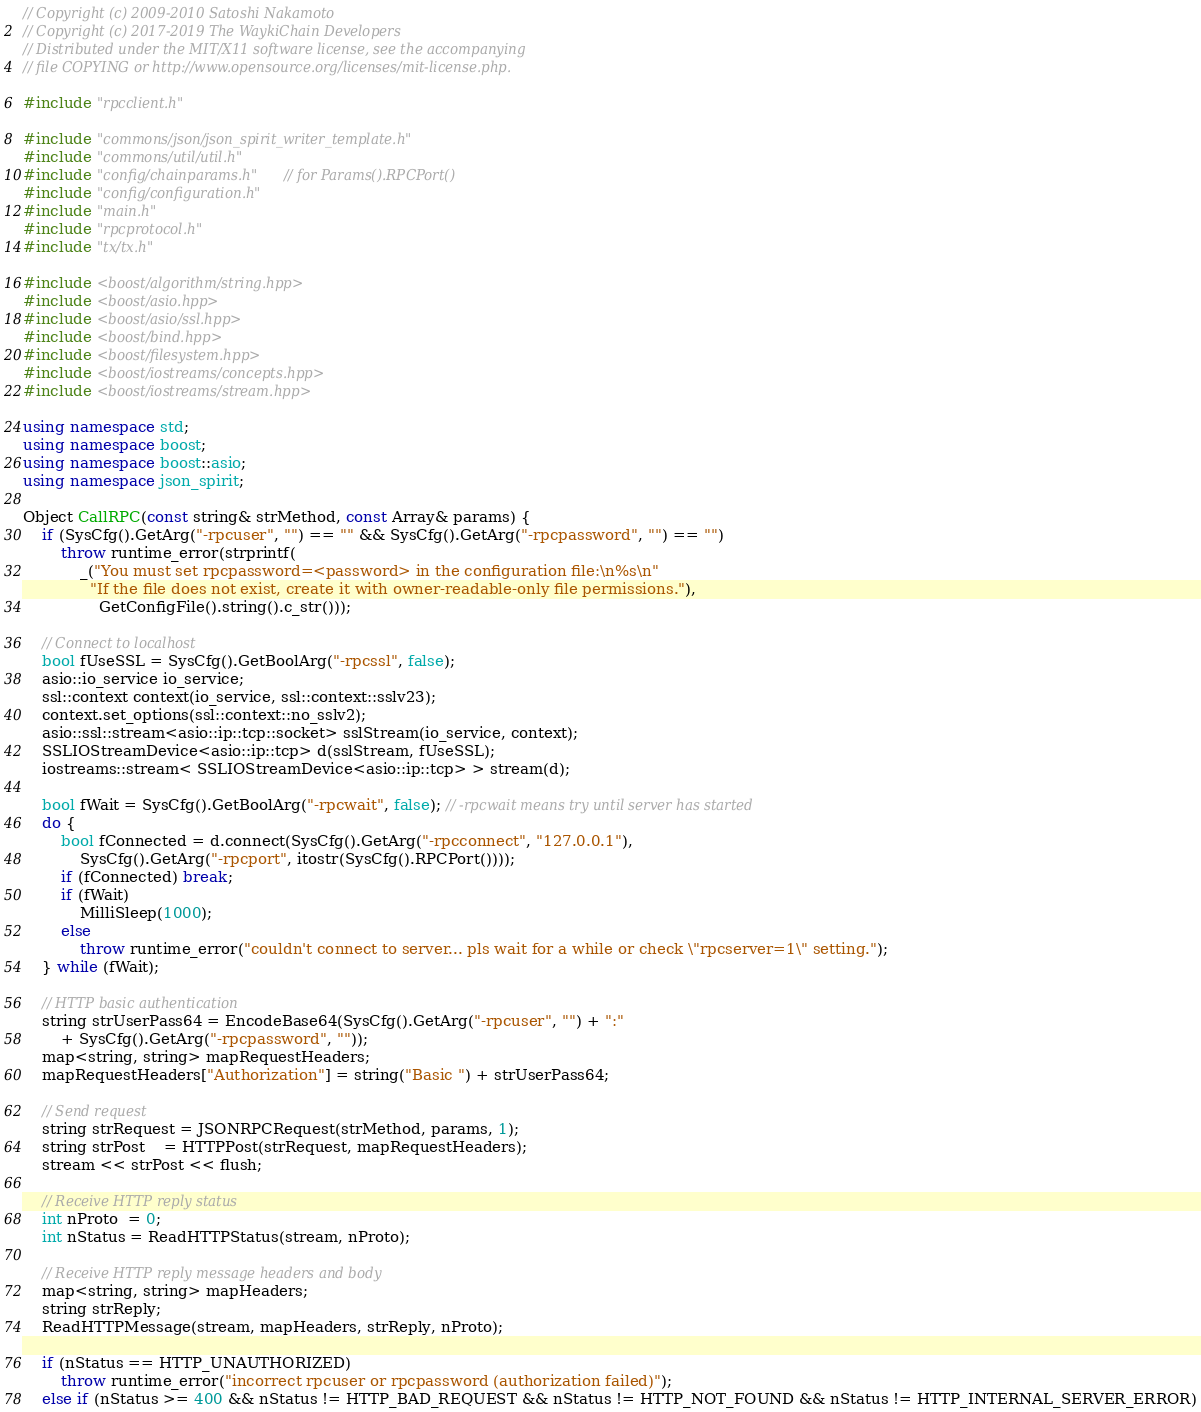<code> <loc_0><loc_0><loc_500><loc_500><_C++_>// Copyright (c) 2009-2010 Satoshi Nakamoto
// Copyright (c) 2017-2019 The WaykiChain Developers
// Distributed under the MIT/X11 software license, see the accompanying
// file COPYING or http://www.opensource.org/licenses/mit-license.php.

#include "rpcclient.h"

#include "commons/json/json_spirit_writer_template.h"
#include "commons/util/util.h"
#include "config/chainparams.h"  // for Params().RPCPort()
#include "config/configuration.h"
#include "main.h"
#include "rpcprotocol.h"
#include "tx/tx.h"

#include <boost/algorithm/string.hpp>
#include <boost/asio.hpp>
#include <boost/asio/ssl.hpp>
#include <boost/bind.hpp>
#include <boost/filesystem.hpp>
#include <boost/iostreams/concepts.hpp>
#include <boost/iostreams/stream.hpp>

using namespace std;
using namespace boost;
using namespace boost::asio;
using namespace json_spirit;

Object CallRPC(const string& strMethod, const Array& params) {
    if (SysCfg().GetArg("-rpcuser", "") == "" && SysCfg().GetArg("-rpcpassword", "") == "")
        throw runtime_error(strprintf(
            _("You must set rpcpassword=<password> in the configuration file:\n%s\n"
              "If the file does not exist, create it with owner-readable-only file permissions."),
                GetConfigFile().string().c_str()));

    // Connect to localhost
    bool fUseSSL = SysCfg().GetBoolArg("-rpcssl", false);
    asio::io_service io_service;
    ssl::context context(io_service, ssl::context::sslv23);
    context.set_options(ssl::context::no_sslv2);
    asio::ssl::stream<asio::ip::tcp::socket> sslStream(io_service, context);
    SSLIOStreamDevice<asio::ip::tcp> d(sslStream, fUseSSL);
    iostreams::stream< SSLIOStreamDevice<asio::ip::tcp> > stream(d);

    bool fWait = SysCfg().GetBoolArg("-rpcwait", false); // -rpcwait means try until server has started
    do {
        bool fConnected = d.connect(SysCfg().GetArg("-rpcconnect", "127.0.0.1"),
            SysCfg().GetArg("-rpcport", itostr(SysCfg().RPCPort())));
        if (fConnected) break;
        if (fWait)
            MilliSleep(1000);
        else
            throw runtime_error("couldn't connect to server... pls wait for a while or check \"rpcserver=1\" setting.");
    } while (fWait);

    // HTTP basic authentication
    string strUserPass64 = EncodeBase64(SysCfg().GetArg("-rpcuser", "") + ":"
        + SysCfg().GetArg("-rpcpassword", ""));
    map<string, string> mapRequestHeaders;
    mapRequestHeaders["Authorization"] = string("Basic ") + strUserPass64;

    // Send request
    string strRequest = JSONRPCRequest(strMethod, params, 1);
    string strPost    = HTTPPost(strRequest, mapRequestHeaders);
    stream << strPost << flush;

    // Receive HTTP reply status
    int nProto  = 0;
    int nStatus = ReadHTTPStatus(stream, nProto);

    // Receive HTTP reply message headers and body
    map<string, string> mapHeaders;
    string strReply;
    ReadHTTPMessage(stream, mapHeaders, strReply, nProto);

    if (nStatus == HTTP_UNAUTHORIZED)
        throw runtime_error("incorrect rpcuser or rpcpassword (authorization failed)");
    else if (nStatus >= 400 && nStatus != HTTP_BAD_REQUEST && nStatus != HTTP_NOT_FOUND && nStatus != HTTP_INTERNAL_SERVER_ERROR)</code> 